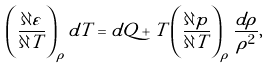Convert formula to latex. <formula><loc_0><loc_0><loc_500><loc_500>\left ( \frac { \partial \varepsilon } { \partial T } \right ) _ { \rho } d T = d Q + T \left ( \frac { \partial p } { \partial T } \right ) _ { \rho } \frac { d \rho } { \rho ^ { 2 } } ,</formula> 